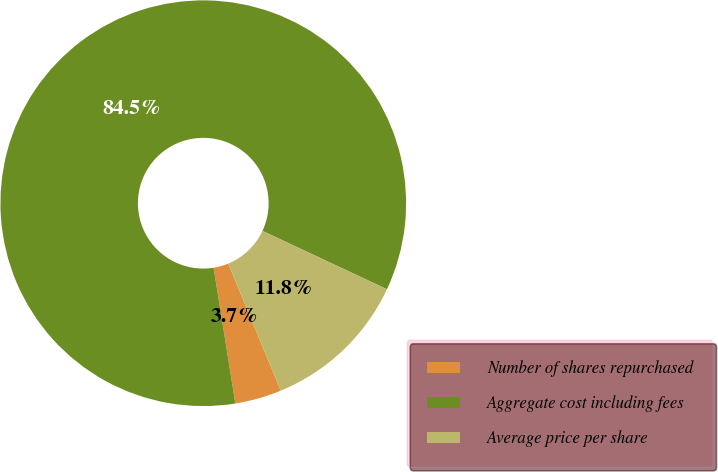Convert chart. <chart><loc_0><loc_0><loc_500><loc_500><pie_chart><fcel>Number of shares repurchased<fcel>Aggregate cost including fees<fcel>Average price per share<nl><fcel>3.71%<fcel>84.51%<fcel>11.79%<nl></chart> 